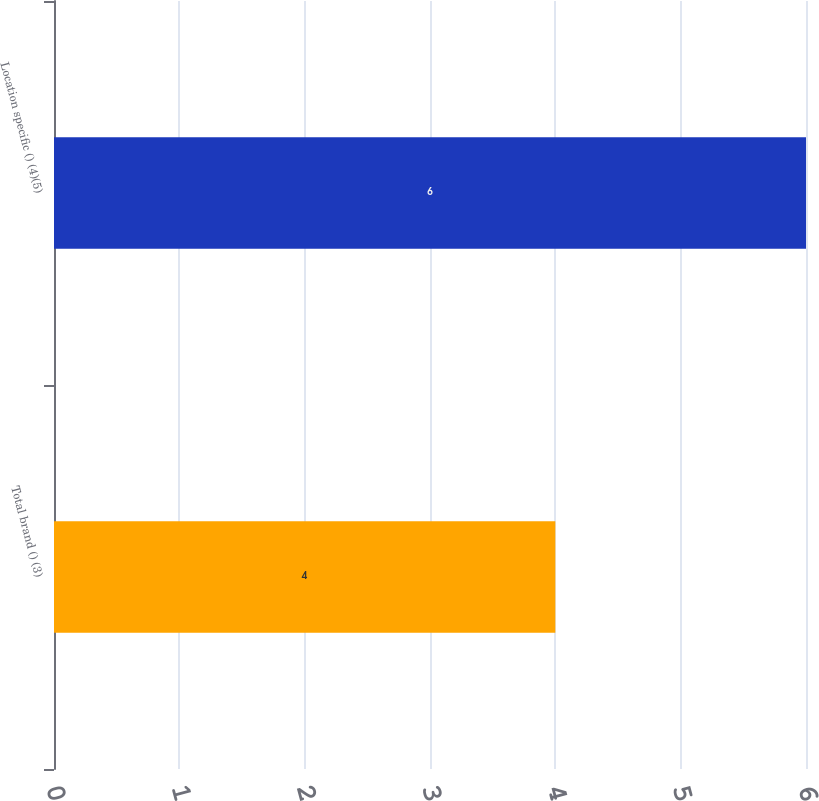Convert chart. <chart><loc_0><loc_0><loc_500><loc_500><bar_chart><fcel>Total brand () (3)<fcel>Location specific () (4)(5)<nl><fcel>4<fcel>6<nl></chart> 